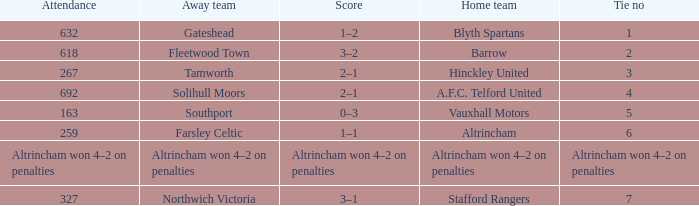Which home team was playing against the away team southport? Vauxhall Motors. 